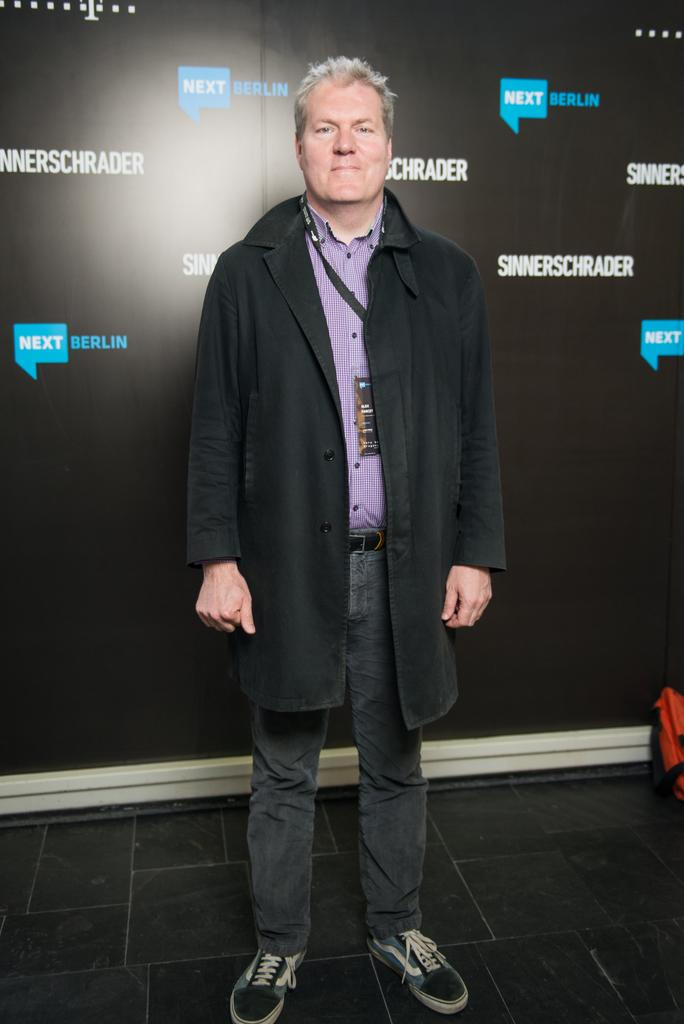What is the person in the image doing? The person is standing in the image. Where is the person standing? The person is standing on the floor. What is the person wearing? The person is wearing a jacket. What else can be seen in the image besides the person? There is a banner visible in the image, and there is a bag on the floor on the right side of the image. What type of throne is the person sitting on in the image? There is no throne present in the image; the person is standing on the floor. What color are the bricks that make up the wall in the image? There is no wall made of bricks visible in the image. Can you see any jellyfish swimming in the image? There are no jellyfish present in the image. 